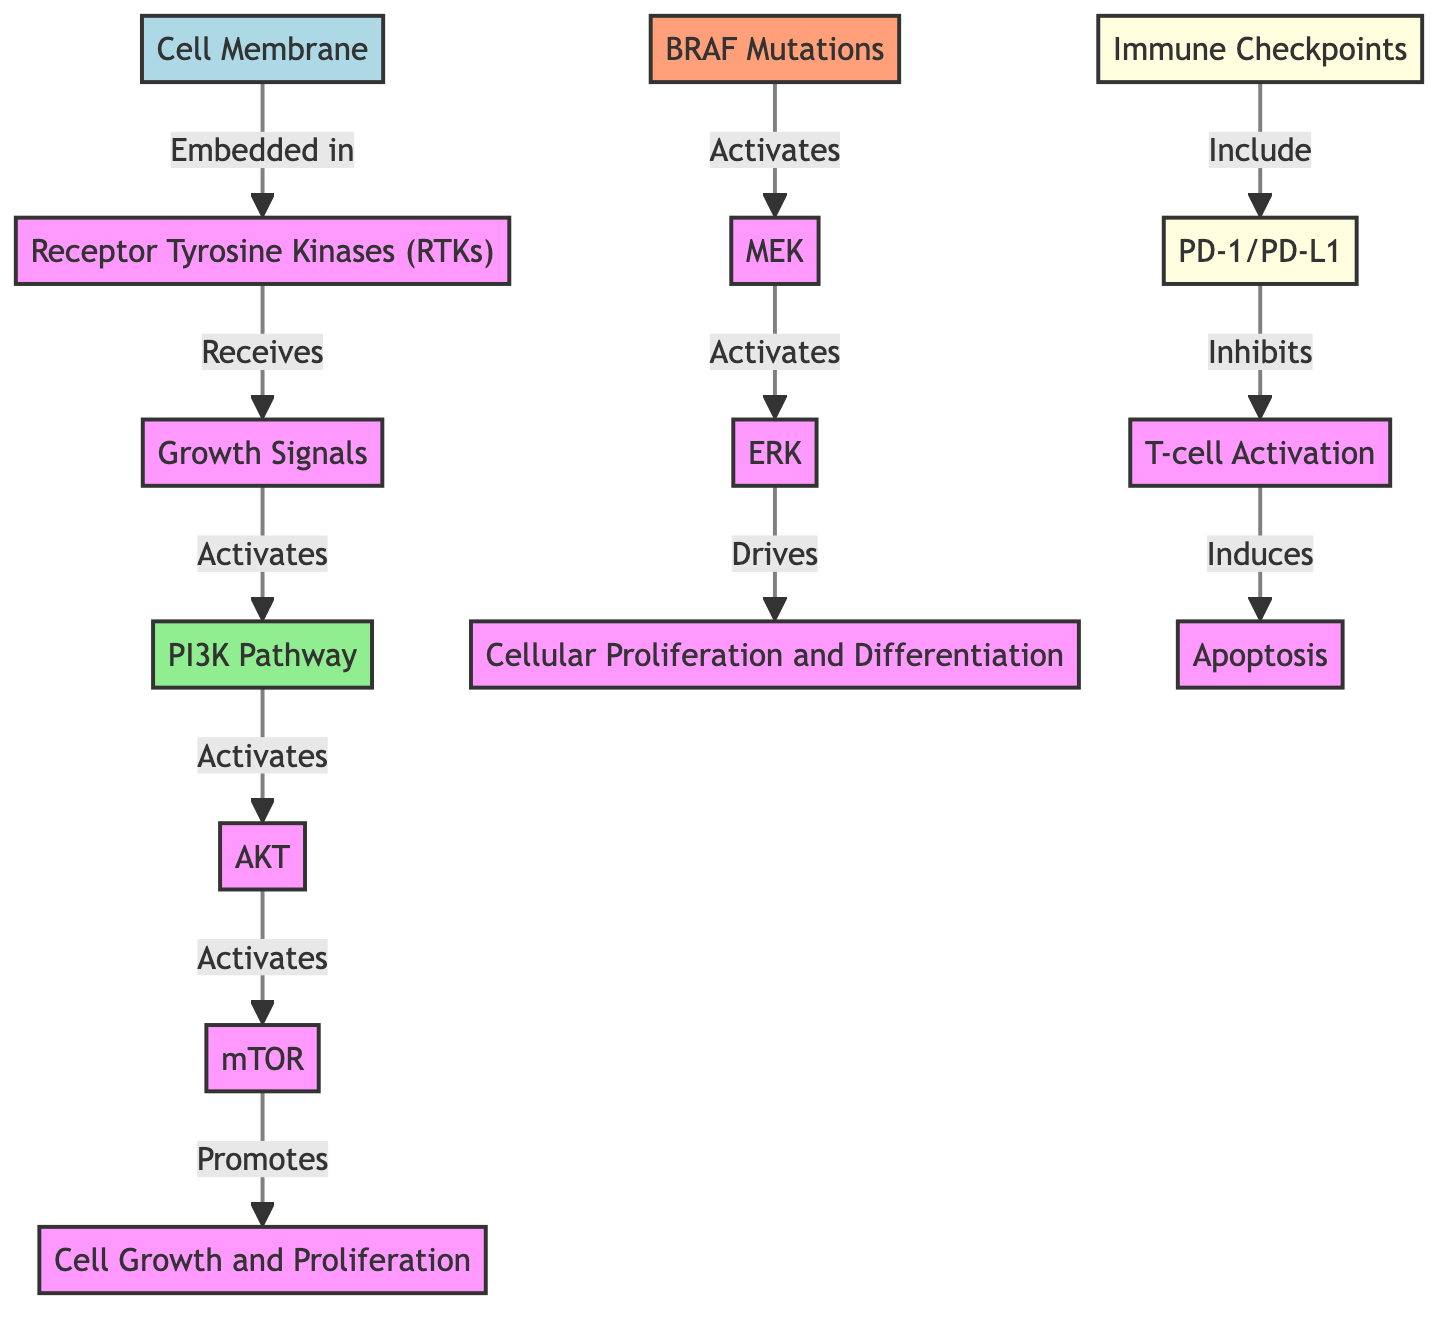What is the first node in the diagram? The first node is "Cell Membrane" as it is the starting point where the process is initiated before any signals are received by the receptor.
Answer: Cell Membrane How many pathways are shown in the diagram? There are two main pathways depicted: the PI3K pathway and the MAPK pathway (involving BRAF, MEK, and ERK).
Answer: 2 What role does mTOR play in the diagram? mTOR promotes cell growth and proliferation, indicating it is a key factor in the signaling that leads to these processes.
Answer: Promotes cell growth and proliferation What does PD-1/PD-L1 inhibit? PD-1/PD-L1 inhibits T-cell activation, which is necessary for the immune response against cancer cells.
Answer: T-cell activation Which mutation activates MEK? BRAF mutations activate MEK, highlighting the mutation's significance in the signaling pathway for cellular proliferation and differentiation.
Answer: BRAF mutations What kind of cells does T-cell activation induce apoptosis in? T-cell activation induces apoptosis in cancer cells, which is a critical step in the immune response to eliminate these cells.
Answer: Cancer cells What does the PI3K pathway activate? The PI3K pathway activates AKT, which is a central player in signaling pathways related to cell growth and survival.
Answer: AKT How many immune checkpoints are indicated in the diagram? There is one immune checkpoint indicated in the diagram, which is PD-1/PD-L1.
Answer: 1 What is the final outcome of T-cell activation in the diagram? The final outcome of T-cell activation is apoptosis, which signifies the end of that signaling pathway aimed at eliminating cancer cells.
Answer: Apoptosis 